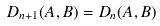<formula> <loc_0><loc_0><loc_500><loc_500>D _ { n + 1 } ( A , B ) = D _ { n } ( A , B )</formula> 